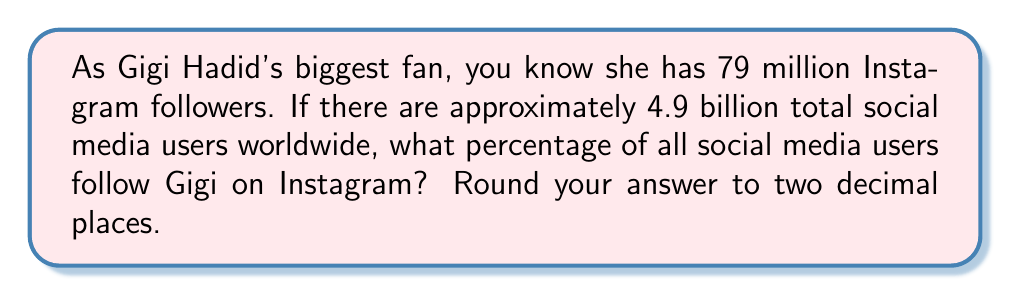Help me with this question. To calculate the percentage of Gigi Hadid's Instagram followers compared to total social media users, we'll use the following formula:

$$ \text{Percentage} = \frac{\text{Gigi's followers}}{\text{Total social media users}} \times 100\% $$

Let's plug in the numbers:

1. Gigi's Instagram followers: 79 million
2. Total social media users: 4.9 billion

First, we need to convert both numbers to the same unit (millions):
$$ 4.9 \text{ billion} = 4,900 \text{ million} $$

Now, we can calculate the percentage:

$$ \text{Percentage} = \frac{79}{4,900} \times 100\% $$

$$ = 0.016122449 \times 100\% $$

$$ = 1.6122449\% $$

Rounding to two decimal places:

$$ 1.61\% $$
Answer: 1.61% 